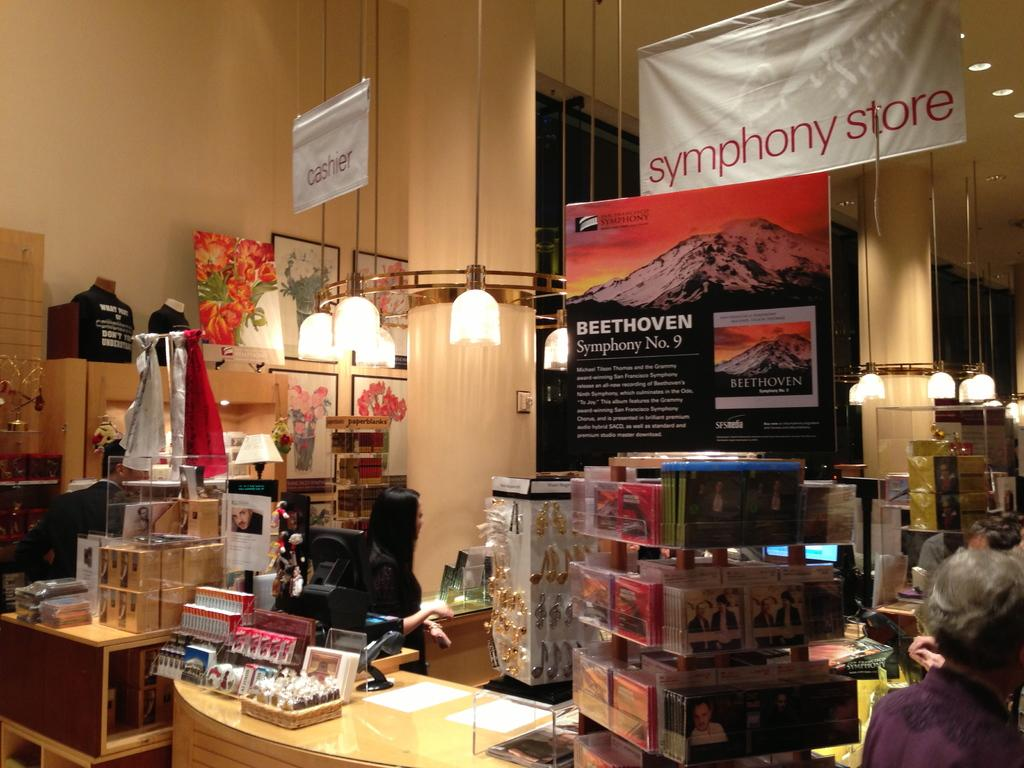Provide a one-sentence caption for the provided image. A display and cash register inside the symphony store. 